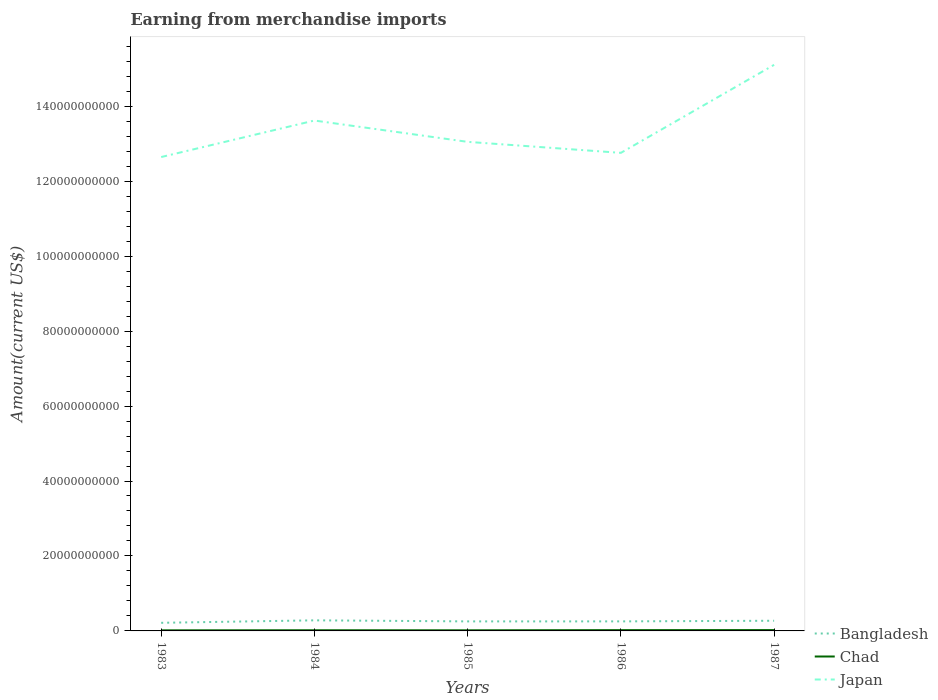How many different coloured lines are there?
Provide a succinct answer. 3. Is the number of lines equal to the number of legend labels?
Your response must be concise. Yes. Across all years, what is the maximum amount earned from merchandise imports in Japan?
Make the answer very short. 1.26e+11. In which year was the amount earned from merchandise imports in Japan maximum?
Offer a very short reply. 1983. What is the total amount earned from merchandise imports in Chad in the graph?
Provide a succinct answer. -4.50e+07. What is the difference between the highest and the second highest amount earned from merchandise imports in Chad?
Your answer should be very brief. 6.90e+07. Does the graph contain any zero values?
Give a very brief answer. No. Does the graph contain grids?
Make the answer very short. No. How many legend labels are there?
Provide a succinct answer. 3. How are the legend labels stacked?
Your answer should be very brief. Vertical. What is the title of the graph?
Ensure brevity in your answer.  Earning from merchandise imports. What is the label or title of the Y-axis?
Ensure brevity in your answer.  Amount(current US$). What is the Amount(current US$) of Bangladesh in 1983?
Provide a succinct answer. 2.16e+09. What is the Amount(current US$) of Chad in 1983?
Provide a short and direct response. 1.57e+08. What is the Amount(current US$) in Japan in 1983?
Ensure brevity in your answer.  1.26e+11. What is the Amount(current US$) in Bangladesh in 1984?
Keep it short and to the point. 2.82e+09. What is the Amount(current US$) of Chad in 1984?
Keep it short and to the point. 1.81e+08. What is the Amount(current US$) of Japan in 1984?
Provide a succinct answer. 1.36e+11. What is the Amount(current US$) in Bangladesh in 1985?
Give a very brief answer. 2.54e+09. What is the Amount(current US$) of Chad in 1985?
Your answer should be very brief. 1.66e+08. What is the Amount(current US$) of Japan in 1985?
Your answer should be compact. 1.30e+11. What is the Amount(current US$) of Bangladesh in 1986?
Your response must be concise. 2.55e+09. What is the Amount(current US$) in Chad in 1986?
Your answer should be very brief. 2.12e+08. What is the Amount(current US$) of Japan in 1986?
Offer a very short reply. 1.28e+11. What is the Amount(current US$) in Bangladesh in 1987?
Keep it short and to the point. 2.72e+09. What is the Amount(current US$) of Chad in 1987?
Keep it short and to the point. 2.26e+08. What is the Amount(current US$) of Japan in 1987?
Offer a terse response. 1.51e+11. Across all years, what is the maximum Amount(current US$) in Bangladesh?
Your answer should be compact. 2.82e+09. Across all years, what is the maximum Amount(current US$) of Chad?
Your response must be concise. 2.26e+08. Across all years, what is the maximum Amount(current US$) in Japan?
Offer a very short reply. 1.51e+11. Across all years, what is the minimum Amount(current US$) in Bangladesh?
Provide a short and direct response. 2.16e+09. Across all years, what is the minimum Amount(current US$) of Chad?
Make the answer very short. 1.57e+08. Across all years, what is the minimum Amount(current US$) of Japan?
Make the answer very short. 1.26e+11. What is the total Amount(current US$) in Bangladesh in the graph?
Keep it short and to the point. 1.28e+1. What is the total Amount(current US$) of Chad in the graph?
Your answer should be very brief. 9.42e+08. What is the total Amount(current US$) in Japan in the graph?
Offer a terse response. 6.72e+11. What is the difference between the Amount(current US$) in Bangladesh in 1983 and that in 1984?
Your answer should be very brief. -6.60e+08. What is the difference between the Amount(current US$) in Chad in 1983 and that in 1984?
Keep it short and to the point. -2.40e+07. What is the difference between the Amount(current US$) of Japan in 1983 and that in 1984?
Your answer should be very brief. -9.74e+09. What is the difference between the Amount(current US$) in Bangladesh in 1983 and that in 1985?
Give a very brief answer. -3.77e+08. What is the difference between the Amount(current US$) in Chad in 1983 and that in 1985?
Your answer should be very brief. -9.00e+06. What is the difference between the Amount(current US$) in Japan in 1983 and that in 1985?
Provide a short and direct response. -4.05e+09. What is the difference between the Amount(current US$) in Bangladesh in 1983 and that in 1986?
Provide a short and direct response. -3.81e+08. What is the difference between the Amount(current US$) in Chad in 1983 and that in 1986?
Provide a short and direct response. -5.50e+07. What is the difference between the Amount(current US$) in Japan in 1983 and that in 1986?
Your answer should be very brief. -1.12e+09. What is the difference between the Amount(current US$) of Bangladesh in 1983 and that in 1987?
Provide a succinct answer. -5.50e+08. What is the difference between the Amount(current US$) in Chad in 1983 and that in 1987?
Keep it short and to the point. -6.90e+07. What is the difference between the Amount(current US$) of Japan in 1983 and that in 1987?
Offer a terse response. -2.46e+1. What is the difference between the Amount(current US$) of Bangladesh in 1984 and that in 1985?
Your answer should be very brief. 2.83e+08. What is the difference between the Amount(current US$) in Chad in 1984 and that in 1985?
Give a very brief answer. 1.50e+07. What is the difference between the Amount(current US$) in Japan in 1984 and that in 1985?
Provide a succinct answer. 5.69e+09. What is the difference between the Amount(current US$) of Bangladesh in 1984 and that in 1986?
Make the answer very short. 2.79e+08. What is the difference between the Amount(current US$) in Chad in 1984 and that in 1986?
Give a very brief answer. -3.10e+07. What is the difference between the Amount(current US$) of Japan in 1984 and that in 1986?
Your answer should be very brief. 8.62e+09. What is the difference between the Amount(current US$) of Bangladesh in 1984 and that in 1987?
Provide a succinct answer. 1.10e+08. What is the difference between the Amount(current US$) of Chad in 1984 and that in 1987?
Give a very brief answer. -4.50e+07. What is the difference between the Amount(current US$) in Japan in 1984 and that in 1987?
Keep it short and to the point. -1.49e+1. What is the difference between the Amount(current US$) in Bangladesh in 1985 and that in 1986?
Offer a very short reply. -4.00e+06. What is the difference between the Amount(current US$) in Chad in 1985 and that in 1986?
Keep it short and to the point. -4.60e+07. What is the difference between the Amount(current US$) of Japan in 1985 and that in 1986?
Keep it short and to the point. 2.94e+09. What is the difference between the Amount(current US$) in Bangladesh in 1985 and that in 1987?
Your answer should be very brief. -1.73e+08. What is the difference between the Amount(current US$) of Chad in 1985 and that in 1987?
Your answer should be very brief. -6.00e+07. What is the difference between the Amount(current US$) of Japan in 1985 and that in 1987?
Give a very brief answer. -2.05e+1. What is the difference between the Amount(current US$) in Bangladesh in 1986 and that in 1987?
Provide a succinct answer. -1.69e+08. What is the difference between the Amount(current US$) of Chad in 1986 and that in 1987?
Your answer should be very brief. -1.40e+07. What is the difference between the Amount(current US$) of Japan in 1986 and that in 1987?
Provide a succinct answer. -2.35e+1. What is the difference between the Amount(current US$) in Bangladesh in 1983 and the Amount(current US$) in Chad in 1984?
Your answer should be compact. 1.98e+09. What is the difference between the Amount(current US$) in Bangladesh in 1983 and the Amount(current US$) in Japan in 1984?
Provide a short and direct response. -1.34e+11. What is the difference between the Amount(current US$) in Chad in 1983 and the Amount(current US$) in Japan in 1984?
Ensure brevity in your answer.  -1.36e+11. What is the difference between the Amount(current US$) of Bangladesh in 1983 and the Amount(current US$) of Chad in 1985?
Provide a short and direct response. 2.00e+09. What is the difference between the Amount(current US$) of Bangladesh in 1983 and the Amount(current US$) of Japan in 1985?
Your answer should be very brief. -1.28e+11. What is the difference between the Amount(current US$) in Chad in 1983 and the Amount(current US$) in Japan in 1985?
Your answer should be compact. -1.30e+11. What is the difference between the Amount(current US$) in Bangladesh in 1983 and the Amount(current US$) in Chad in 1986?
Give a very brief answer. 1.95e+09. What is the difference between the Amount(current US$) in Bangladesh in 1983 and the Amount(current US$) in Japan in 1986?
Provide a short and direct response. -1.25e+11. What is the difference between the Amount(current US$) in Chad in 1983 and the Amount(current US$) in Japan in 1986?
Offer a terse response. -1.27e+11. What is the difference between the Amount(current US$) of Bangladesh in 1983 and the Amount(current US$) of Chad in 1987?
Your response must be concise. 1.94e+09. What is the difference between the Amount(current US$) of Bangladesh in 1983 and the Amount(current US$) of Japan in 1987?
Your answer should be very brief. -1.49e+11. What is the difference between the Amount(current US$) in Chad in 1983 and the Amount(current US$) in Japan in 1987?
Offer a terse response. -1.51e+11. What is the difference between the Amount(current US$) of Bangladesh in 1984 and the Amount(current US$) of Chad in 1985?
Give a very brief answer. 2.66e+09. What is the difference between the Amount(current US$) in Bangladesh in 1984 and the Amount(current US$) in Japan in 1985?
Ensure brevity in your answer.  -1.28e+11. What is the difference between the Amount(current US$) in Chad in 1984 and the Amount(current US$) in Japan in 1985?
Keep it short and to the point. -1.30e+11. What is the difference between the Amount(current US$) in Bangladesh in 1984 and the Amount(current US$) in Chad in 1986?
Provide a succinct answer. 2.61e+09. What is the difference between the Amount(current US$) of Bangladesh in 1984 and the Amount(current US$) of Japan in 1986?
Your answer should be compact. -1.25e+11. What is the difference between the Amount(current US$) in Chad in 1984 and the Amount(current US$) in Japan in 1986?
Give a very brief answer. -1.27e+11. What is the difference between the Amount(current US$) of Bangladesh in 1984 and the Amount(current US$) of Chad in 1987?
Make the answer very short. 2.60e+09. What is the difference between the Amount(current US$) of Bangladesh in 1984 and the Amount(current US$) of Japan in 1987?
Your answer should be very brief. -1.48e+11. What is the difference between the Amount(current US$) in Chad in 1984 and the Amount(current US$) in Japan in 1987?
Give a very brief answer. -1.51e+11. What is the difference between the Amount(current US$) in Bangladesh in 1985 and the Amount(current US$) in Chad in 1986?
Your answer should be compact. 2.33e+09. What is the difference between the Amount(current US$) in Bangladesh in 1985 and the Amount(current US$) in Japan in 1986?
Provide a short and direct response. -1.25e+11. What is the difference between the Amount(current US$) in Chad in 1985 and the Amount(current US$) in Japan in 1986?
Make the answer very short. -1.27e+11. What is the difference between the Amount(current US$) of Bangladesh in 1985 and the Amount(current US$) of Chad in 1987?
Your response must be concise. 2.32e+09. What is the difference between the Amount(current US$) in Bangladesh in 1985 and the Amount(current US$) in Japan in 1987?
Offer a very short reply. -1.48e+11. What is the difference between the Amount(current US$) of Chad in 1985 and the Amount(current US$) of Japan in 1987?
Your answer should be very brief. -1.51e+11. What is the difference between the Amount(current US$) of Bangladesh in 1986 and the Amount(current US$) of Chad in 1987?
Ensure brevity in your answer.  2.32e+09. What is the difference between the Amount(current US$) in Bangladesh in 1986 and the Amount(current US$) in Japan in 1987?
Your answer should be very brief. -1.48e+11. What is the difference between the Amount(current US$) of Chad in 1986 and the Amount(current US$) of Japan in 1987?
Ensure brevity in your answer.  -1.51e+11. What is the average Amount(current US$) of Bangladesh per year?
Provide a short and direct response. 2.56e+09. What is the average Amount(current US$) in Chad per year?
Provide a short and direct response. 1.88e+08. What is the average Amount(current US$) of Japan per year?
Ensure brevity in your answer.  1.34e+11. In the year 1983, what is the difference between the Amount(current US$) in Bangladesh and Amount(current US$) in Chad?
Provide a short and direct response. 2.01e+09. In the year 1983, what is the difference between the Amount(current US$) of Bangladesh and Amount(current US$) of Japan?
Your response must be concise. -1.24e+11. In the year 1983, what is the difference between the Amount(current US$) of Chad and Amount(current US$) of Japan?
Ensure brevity in your answer.  -1.26e+11. In the year 1984, what is the difference between the Amount(current US$) of Bangladesh and Amount(current US$) of Chad?
Give a very brief answer. 2.64e+09. In the year 1984, what is the difference between the Amount(current US$) of Bangladesh and Amount(current US$) of Japan?
Offer a terse response. -1.33e+11. In the year 1984, what is the difference between the Amount(current US$) of Chad and Amount(current US$) of Japan?
Keep it short and to the point. -1.36e+11. In the year 1985, what is the difference between the Amount(current US$) in Bangladesh and Amount(current US$) in Chad?
Provide a short and direct response. 2.38e+09. In the year 1985, what is the difference between the Amount(current US$) in Bangladesh and Amount(current US$) in Japan?
Offer a terse response. -1.28e+11. In the year 1985, what is the difference between the Amount(current US$) of Chad and Amount(current US$) of Japan?
Ensure brevity in your answer.  -1.30e+11. In the year 1986, what is the difference between the Amount(current US$) in Bangladesh and Amount(current US$) in Chad?
Provide a succinct answer. 2.33e+09. In the year 1986, what is the difference between the Amount(current US$) of Bangladesh and Amount(current US$) of Japan?
Provide a short and direct response. -1.25e+11. In the year 1986, what is the difference between the Amount(current US$) in Chad and Amount(current US$) in Japan?
Ensure brevity in your answer.  -1.27e+11. In the year 1987, what is the difference between the Amount(current US$) of Bangladesh and Amount(current US$) of Chad?
Keep it short and to the point. 2.49e+09. In the year 1987, what is the difference between the Amount(current US$) of Bangladesh and Amount(current US$) of Japan?
Give a very brief answer. -1.48e+11. In the year 1987, what is the difference between the Amount(current US$) of Chad and Amount(current US$) of Japan?
Keep it short and to the point. -1.51e+11. What is the ratio of the Amount(current US$) in Bangladesh in 1983 to that in 1984?
Provide a succinct answer. 0.77. What is the ratio of the Amount(current US$) of Chad in 1983 to that in 1984?
Give a very brief answer. 0.87. What is the ratio of the Amount(current US$) of Japan in 1983 to that in 1984?
Give a very brief answer. 0.93. What is the ratio of the Amount(current US$) of Bangladesh in 1983 to that in 1985?
Offer a terse response. 0.85. What is the ratio of the Amount(current US$) in Chad in 1983 to that in 1985?
Provide a succinct answer. 0.95. What is the ratio of the Amount(current US$) of Japan in 1983 to that in 1985?
Provide a short and direct response. 0.97. What is the ratio of the Amount(current US$) in Bangladesh in 1983 to that in 1986?
Offer a terse response. 0.85. What is the ratio of the Amount(current US$) in Chad in 1983 to that in 1986?
Offer a terse response. 0.74. What is the ratio of the Amount(current US$) in Japan in 1983 to that in 1986?
Make the answer very short. 0.99. What is the ratio of the Amount(current US$) of Bangladesh in 1983 to that in 1987?
Your answer should be compact. 0.8. What is the ratio of the Amount(current US$) of Chad in 1983 to that in 1987?
Your answer should be very brief. 0.69. What is the ratio of the Amount(current US$) of Japan in 1983 to that in 1987?
Offer a very short reply. 0.84. What is the ratio of the Amount(current US$) of Bangladesh in 1984 to that in 1985?
Your answer should be compact. 1.11. What is the ratio of the Amount(current US$) of Chad in 1984 to that in 1985?
Provide a succinct answer. 1.09. What is the ratio of the Amount(current US$) of Japan in 1984 to that in 1985?
Your response must be concise. 1.04. What is the ratio of the Amount(current US$) in Bangladesh in 1984 to that in 1986?
Your answer should be compact. 1.11. What is the ratio of the Amount(current US$) of Chad in 1984 to that in 1986?
Your answer should be very brief. 0.85. What is the ratio of the Amount(current US$) of Japan in 1984 to that in 1986?
Keep it short and to the point. 1.07. What is the ratio of the Amount(current US$) in Bangladesh in 1984 to that in 1987?
Give a very brief answer. 1.04. What is the ratio of the Amount(current US$) of Chad in 1984 to that in 1987?
Your response must be concise. 0.8. What is the ratio of the Amount(current US$) in Japan in 1984 to that in 1987?
Provide a short and direct response. 0.9. What is the ratio of the Amount(current US$) in Chad in 1985 to that in 1986?
Ensure brevity in your answer.  0.78. What is the ratio of the Amount(current US$) in Bangladesh in 1985 to that in 1987?
Provide a short and direct response. 0.94. What is the ratio of the Amount(current US$) of Chad in 1985 to that in 1987?
Make the answer very short. 0.73. What is the ratio of the Amount(current US$) of Japan in 1985 to that in 1987?
Offer a very short reply. 0.86. What is the ratio of the Amount(current US$) in Bangladesh in 1986 to that in 1987?
Your answer should be very brief. 0.94. What is the ratio of the Amount(current US$) of Chad in 1986 to that in 1987?
Keep it short and to the point. 0.94. What is the ratio of the Amount(current US$) of Japan in 1986 to that in 1987?
Provide a short and direct response. 0.84. What is the difference between the highest and the second highest Amount(current US$) in Bangladesh?
Ensure brevity in your answer.  1.10e+08. What is the difference between the highest and the second highest Amount(current US$) in Chad?
Offer a terse response. 1.40e+07. What is the difference between the highest and the second highest Amount(current US$) of Japan?
Provide a succinct answer. 1.49e+1. What is the difference between the highest and the lowest Amount(current US$) of Bangladesh?
Keep it short and to the point. 6.60e+08. What is the difference between the highest and the lowest Amount(current US$) of Chad?
Provide a short and direct response. 6.90e+07. What is the difference between the highest and the lowest Amount(current US$) of Japan?
Offer a very short reply. 2.46e+1. 